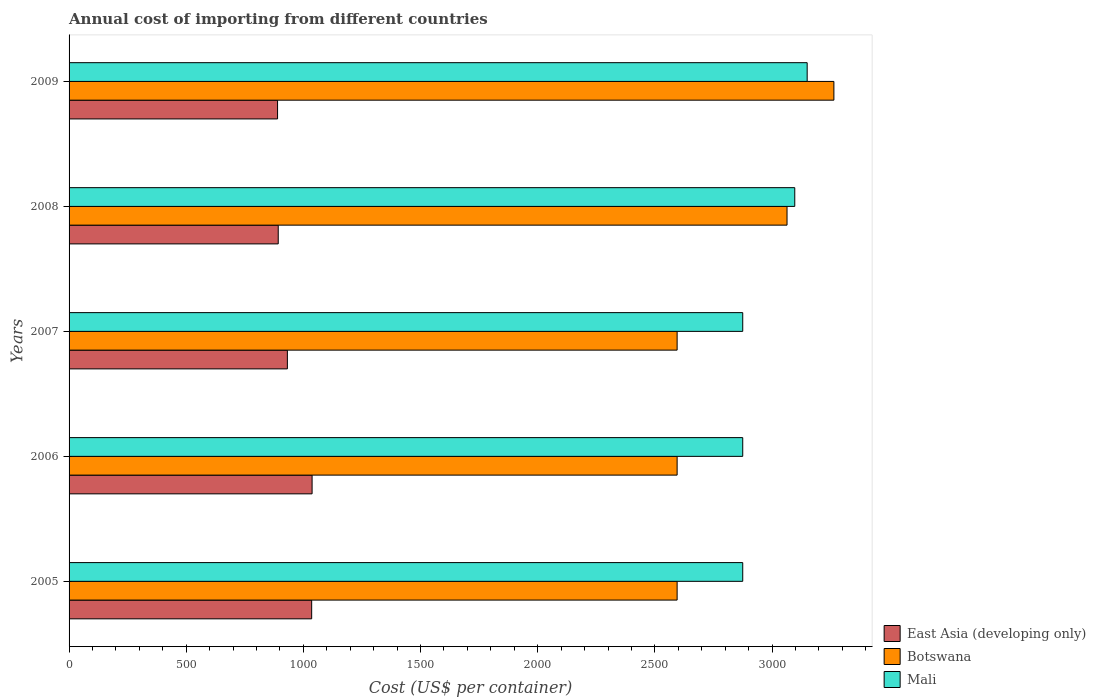Are the number of bars per tick equal to the number of legend labels?
Keep it short and to the point. Yes. Are the number of bars on each tick of the Y-axis equal?
Your answer should be very brief. Yes. How many bars are there on the 4th tick from the top?
Offer a terse response. 3. How many bars are there on the 4th tick from the bottom?
Your response must be concise. 3. In how many cases, is the number of bars for a given year not equal to the number of legend labels?
Provide a succinct answer. 0. What is the total annual cost of importing in Mali in 2009?
Your answer should be very brief. 3150. Across all years, what is the maximum total annual cost of importing in Botswana?
Keep it short and to the point. 3264. Across all years, what is the minimum total annual cost of importing in Botswana?
Give a very brief answer. 2595. In which year was the total annual cost of importing in Mali maximum?
Offer a terse response. 2009. What is the total total annual cost of importing in Botswana in the graph?
Make the answer very short. 1.41e+04. What is the difference between the total annual cost of importing in East Asia (developing only) in 2006 and that in 2007?
Give a very brief answer. 105.5. What is the difference between the total annual cost of importing in Mali in 2006 and the total annual cost of importing in East Asia (developing only) in 2008?
Keep it short and to the point. 1982.35. What is the average total annual cost of importing in Mali per year?
Your answer should be very brief. 2974.4. In the year 2007, what is the difference between the total annual cost of importing in East Asia (developing only) and total annual cost of importing in Mali?
Your response must be concise. -1943.35. In how many years, is the total annual cost of importing in Botswana greater than 400 US$?
Ensure brevity in your answer.  5. What is the ratio of the total annual cost of importing in Botswana in 2007 to that in 2008?
Your answer should be compact. 0.85. Is the total annual cost of importing in East Asia (developing only) in 2007 less than that in 2009?
Offer a terse response. No. Is the difference between the total annual cost of importing in East Asia (developing only) in 2007 and 2009 greater than the difference between the total annual cost of importing in Mali in 2007 and 2009?
Provide a short and direct response. Yes. What is the difference between the highest and the second highest total annual cost of importing in Botswana?
Keep it short and to the point. 200. What is the difference between the highest and the lowest total annual cost of importing in Mali?
Provide a short and direct response. 275. Is the sum of the total annual cost of importing in Mali in 2005 and 2007 greater than the maximum total annual cost of importing in Botswana across all years?
Ensure brevity in your answer.  Yes. What does the 3rd bar from the top in 2005 represents?
Keep it short and to the point. East Asia (developing only). What does the 1st bar from the bottom in 2005 represents?
Give a very brief answer. East Asia (developing only). How many bars are there?
Provide a succinct answer. 15. How many years are there in the graph?
Keep it short and to the point. 5. What is the difference between two consecutive major ticks on the X-axis?
Your answer should be compact. 500. Does the graph contain any zero values?
Offer a very short reply. No. Does the graph contain grids?
Provide a succinct answer. No. Where does the legend appear in the graph?
Offer a very short reply. Bottom right. How many legend labels are there?
Your response must be concise. 3. What is the title of the graph?
Your answer should be very brief. Annual cost of importing from different countries. Does "Senegal" appear as one of the legend labels in the graph?
Ensure brevity in your answer.  No. What is the label or title of the X-axis?
Keep it short and to the point. Cost (US$ per container). What is the label or title of the Y-axis?
Provide a succinct answer. Years. What is the Cost (US$ per container) in East Asia (developing only) in 2005?
Offer a very short reply. 1035.35. What is the Cost (US$ per container) in Botswana in 2005?
Offer a terse response. 2595. What is the Cost (US$ per container) of Mali in 2005?
Ensure brevity in your answer.  2875. What is the Cost (US$ per container) in East Asia (developing only) in 2006?
Provide a short and direct response. 1037.15. What is the Cost (US$ per container) in Botswana in 2006?
Provide a short and direct response. 2595. What is the Cost (US$ per container) of Mali in 2006?
Provide a short and direct response. 2875. What is the Cost (US$ per container) in East Asia (developing only) in 2007?
Your answer should be compact. 931.65. What is the Cost (US$ per container) of Botswana in 2007?
Provide a short and direct response. 2595. What is the Cost (US$ per container) of Mali in 2007?
Keep it short and to the point. 2875. What is the Cost (US$ per container) of East Asia (developing only) in 2008?
Ensure brevity in your answer.  892.65. What is the Cost (US$ per container) in Botswana in 2008?
Your response must be concise. 3064. What is the Cost (US$ per container) in Mali in 2008?
Ensure brevity in your answer.  3097. What is the Cost (US$ per container) in East Asia (developing only) in 2009?
Your response must be concise. 889.75. What is the Cost (US$ per container) in Botswana in 2009?
Offer a very short reply. 3264. What is the Cost (US$ per container) in Mali in 2009?
Your response must be concise. 3150. Across all years, what is the maximum Cost (US$ per container) in East Asia (developing only)?
Ensure brevity in your answer.  1037.15. Across all years, what is the maximum Cost (US$ per container) of Botswana?
Your response must be concise. 3264. Across all years, what is the maximum Cost (US$ per container) in Mali?
Keep it short and to the point. 3150. Across all years, what is the minimum Cost (US$ per container) in East Asia (developing only)?
Offer a very short reply. 889.75. Across all years, what is the minimum Cost (US$ per container) in Botswana?
Make the answer very short. 2595. Across all years, what is the minimum Cost (US$ per container) in Mali?
Your response must be concise. 2875. What is the total Cost (US$ per container) of East Asia (developing only) in the graph?
Your response must be concise. 4786.55. What is the total Cost (US$ per container) of Botswana in the graph?
Offer a terse response. 1.41e+04. What is the total Cost (US$ per container) in Mali in the graph?
Make the answer very short. 1.49e+04. What is the difference between the Cost (US$ per container) in Botswana in 2005 and that in 2006?
Make the answer very short. 0. What is the difference between the Cost (US$ per container) in Mali in 2005 and that in 2006?
Offer a very short reply. 0. What is the difference between the Cost (US$ per container) of East Asia (developing only) in 2005 and that in 2007?
Your answer should be very brief. 103.7. What is the difference between the Cost (US$ per container) of Botswana in 2005 and that in 2007?
Make the answer very short. 0. What is the difference between the Cost (US$ per container) in Mali in 2005 and that in 2007?
Your response must be concise. 0. What is the difference between the Cost (US$ per container) in East Asia (developing only) in 2005 and that in 2008?
Make the answer very short. 142.7. What is the difference between the Cost (US$ per container) in Botswana in 2005 and that in 2008?
Your response must be concise. -469. What is the difference between the Cost (US$ per container) of Mali in 2005 and that in 2008?
Offer a very short reply. -222. What is the difference between the Cost (US$ per container) of East Asia (developing only) in 2005 and that in 2009?
Your response must be concise. 145.6. What is the difference between the Cost (US$ per container) of Botswana in 2005 and that in 2009?
Your answer should be compact. -669. What is the difference between the Cost (US$ per container) of Mali in 2005 and that in 2009?
Offer a very short reply. -275. What is the difference between the Cost (US$ per container) in East Asia (developing only) in 2006 and that in 2007?
Give a very brief answer. 105.5. What is the difference between the Cost (US$ per container) of Mali in 2006 and that in 2007?
Keep it short and to the point. 0. What is the difference between the Cost (US$ per container) in East Asia (developing only) in 2006 and that in 2008?
Make the answer very short. 144.5. What is the difference between the Cost (US$ per container) in Botswana in 2006 and that in 2008?
Your answer should be very brief. -469. What is the difference between the Cost (US$ per container) of Mali in 2006 and that in 2008?
Keep it short and to the point. -222. What is the difference between the Cost (US$ per container) of East Asia (developing only) in 2006 and that in 2009?
Your response must be concise. 147.4. What is the difference between the Cost (US$ per container) of Botswana in 2006 and that in 2009?
Make the answer very short. -669. What is the difference between the Cost (US$ per container) in Mali in 2006 and that in 2009?
Offer a very short reply. -275. What is the difference between the Cost (US$ per container) of Botswana in 2007 and that in 2008?
Offer a very short reply. -469. What is the difference between the Cost (US$ per container) of Mali in 2007 and that in 2008?
Ensure brevity in your answer.  -222. What is the difference between the Cost (US$ per container) in East Asia (developing only) in 2007 and that in 2009?
Provide a succinct answer. 41.9. What is the difference between the Cost (US$ per container) in Botswana in 2007 and that in 2009?
Offer a very short reply. -669. What is the difference between the Cost (US$ per container) in Mali in 2007 and that in 2009?
Keep it short and to the point. -275. What is the difference between the Cost (US$ per container) in East Asia (developing only) in 2008 and that in 2009?
Your answer should be very brief. 2.9. What is the difference between the Cost (US$ per container) in Botswana in 2008 and that in 2009?
Your answer should be very brief. -200. What is the difference between the Cost (US$ per container) of Mali in 2008 and that in 2009?
Offer a very short reply. -53. What is the difference between the Cost (US$ per container) in East Asia (developing only) in 2005 and the Cost (US$ per container) in Botswana in 2006?
Make the answer very short. -1559.65. What is the difference between the Cost (US$ per container) in East Asia (developing only) in 2005 and the Cost (US$ per container) in Mali in 2006?
Give a very brief answer. -1839.65. What is the difference between the Cost (US$ per container) of Botswana in 2005 and the Cost (US$ per container) of Mali in 2006?
Give a very brief answer. -280. What is the difference between the Cost (US$ per container) in East Asia (developing only) in 2005 and the Cost (US$ per container) in Botswana in 2007?
Keep it short and to the point. -1559.65. What is the difference between the Cost (US$ per container) in East Asia (developing only) in 2005 and the Cost (US$ per container) in Mali in 2007?
Provide a succinct answer. -1839.65. What is the difference between the Cost (US$ per container) in Botswana in 2005 and the Cost (US$ per container) in Mali in 2007?
Your response must be concise. -280. What is the difference between the Cost (US$ per container) of East Asia (developing only) in 2005 and the Cost (US$ per container) of Botswana in 2008?
Offer a terse response. -2028.65. What is the difference between the Cost (US$ per container) of East Asia (developing only) in 2005 and the Cost (US$ per container) of Mali in 2008?
Your answer should be very brief. -2061.65. What is the difference between the Cost (US$ per container) of Botswana in 2005 and the Cost (US$ per container) of Mali in 2008?
Your answer should be compact. -502. What is the difference between the Cost (US$ per container) of East Asia (developing only) in 2005 and the Cost (US$ per container) of Botswana in 2009?
Make the answer very short. -2228.65. What is the difference between the Cost (US$ per container) of East Asia (developing only) in 2005 and the Cost (US$ per container) of Mali in 2009?
Your response must be concise. -2114.65. What is the difference between the Cost (US$ per container) in Botswana in 2005 and the Cost (US$ per container) in Mali in 2009?
Provide a succinct answer. -555. What is the difference between the Cost (US$ per container) in East Asia (developing only) in 2006 and the Cost (US$ per container) in Botswana in 2007?
Give a very brief answer. -1557.85. What is the difference between the Cost (US$ per container) of East Asia (developing only) in 2006 and the Cost (US$ per container) of Mali in 2007?
Offer a terse response. -1837.85. What is the difference between the Cost (US$ per container) in Botswana in 2006 and the Cost (US$ per container) in Mali in 2007?
Make the answer very short. -280. What is the difference between the Cost (US$ per container) of East Asia (developing only) in 2006 and the Cost (US$ per container) of Botswana in 2008?
Ensure brevity in your answer.  -2026.85. What is the difference between the Cost (US$ per container) of East Asia (developing only) in 2006 and the Cost (US$ per container) of Mali in 2008?
Keep it short and to the point. -2059.85. What is the difference between the Cost (US$ per container) of Botswana in 2006 and the Cost (US$ per container) of Mali in 2008?
Your answer should be compact. -502. What is the difference between the Cost (US$ per container) of East Asia (developing only) in 2006 and the Cost (US$ per container) of Botswana in 2009?
Provide a short and direct response. -2226.85. What is the difference between the Cost (US$ per container) in East Asia (developing only) in 2006 and the Cost (US$ per container) in Mali in 2009?
Ensure brevity in your answer.  -2112.85. What is the difference between the Cost (US$ per container) in Botswana in 2006 and the Cost (US$ per container) in Mali in 2009?
Your answer should be very brief. -555. What is the difference between the Cost (US$ per container) of East Asia (developing only) in 2007 and the Cost (US$ per container) of Botswana in 2008?
Make the answer very short. -2132.35. What is the difference between the Cost (US$ per container) of East Asia (developing only) in 2007 and the Cost (US$ per container) of Mali in 2008?
Your response must be concise. -2165.35. What is the difference between the Cost (US$ per container) in Botswana in 2007 and the Cost (US$ per container) in Mali in 2008?
Your answer should be very brief. -502. What is the difference between the Cost (US$ per container) of East Asia (developing only) in 2007 and the Cost (US$ per container) of Botswana in 2009?
Ensure brevity in your answer.  -2332.35. What is the difference between the Cost (US$ per container) in East Asia (developing only) in 2007 and the Cost (US$ per container) in Mali in 2009?
Offer a very short reply. -2218.35. What is the difference between the Cost (US$ per container) of Botswana in 2007 and the Cost (US$ per container) of Mali in 2009?
Give a very brief answer. -555. What is the difference between the Cost (US$ per container) in East Asia (developing only) in 2008 and the Cost (US$ per container) in Botswana in 2009?
Make the answer very short. -2371.35. What is the difference between the Cost (US$ per container) of East Asia (developing only) in 2008 and the Cost (US$ per container) of Mali in 2009?
Give a very brief answer. -2257.35. What is the difference between the Cost (US$ per container) in Botswana in 2008 and the Cost (US$ per container) in Mali in 2009?
Offer a very short reply. -86. What is the average Cost (US$ per container) in East Asia (developing only) per year?
Provide a succinct answer. 957.31. What is the average Cost (US$ per container) in Botswana per year?
Provide a short and direct response. 2822.6. What is the average Cost (US$ per container) of Mali per year?
Your answer should be very brief. 2974.4. In the year 2005, what is the difference between the Cost (US$ per container) of East Asia (developing only) and Cost (US$ per container) of Botswana?
Provide a short and direct response. -1559.65. In the year 2005, what is the difference between the Cost (US$ per container) in East Asia (developing only) and Cost (US$ per container) in Mali?
Provide a short and direct response. -1839.65. In the year 2005, what is the difference between the Cost (US$ per container) in Botswana and Cost (US$ per container) in Mali?
Provide a short and direct response. -280. In the year 2006, what is the difference between the Cost (US$ per container) of East Asia (developing only) and Cost (US$ per container) of Botswana?
Your answer should be very brief. -1557.85. In the year 2006, what is the difference between the Cost (US$ per container) in East Asia (developing only) and Cost (US$ per container) in Mali?
Ensure brevity in your answer.  -1837.85. In the year 2006, what is the difference between the Cost (US$ per container) of Botswana and Cost (US$ per container) of Mali?
Make the answer very short. -280. In the year 2007, what is the difference between the Cost (US$ per container) in East Asia (developing only) and Cost (US$ per container) in Botswana?
Give a very brief answer. -1663.35. In the year 2007, what is the difference between the Cost (US$ per container) in East Asia (developing only) and Cost (US$ per container) in Mali?
Provide a short and direct response. -1943.35. In the year 2007, what is the difference between the Cost (US$ per container) in Botswana and Cost (US$ per container) in Mali?
Ensure brevity in your answer.  -280. In the year 2008, what is the difference between the Cost (US$ per container) of East Asia (developing only) and Cost (US$ per container) of Botswana?
Offer a very short reply. -2171.35. In the year 2008, what is the difference between the Cost (US$ per container) in East Asia (developing only) and Cost (US$ per container) in Mali?
Give a very brief answer. -2204.35. In the year 2008, what is the difference between the Cost (US$ per container) in Botswana and Cost (US$ per container) in Mali?
Give a very brief answer. -33. In the year 2009, what is the difference between the Cost (US$ per container) in East Asia (developing only) and Cost (US$ per container) in Botswana?
Your answer should be compact. -2374.25. In the year 2009, what is the difference between the Cost (US$ per container) in East Asia (developing only) and Cost (US$ per container) in Mali?
Offer a terse response. -2260.25. In the year 2009, what is the difference between the Cost (US$ per container) of Botswana and Cost (US$ per container) of Mali?
Provide a succinct answer. 114. What is the ratio of the Cost (US$ per container) of East Asia (developing only) in 2005 to that in 2006?
Give a very brief answer. 1. What is the ratio of the Cost (US$ per container) in East Asia (developing only) in 2005 to that in 2007?
Offer a terse response. 1.11. What is the ratio of the Cost (US$ per container) of Botswana in 2005 to that in 2007?
Your answer should be compact. 1. What is the ratio of the Cost (US$ per container) of Mali in 2005 to that in 2007?
Your answer should be compact. 1. What is the ratio of the Cost (US$ per container) in East Asia (developing only) in 2005 to that in 2008?
Offer a very short reply. 1.16. What is the ratio of the Cost (US$ per container) of Botswana in 2005 to that in 2008?
Give a very brief answer. 0.85. What is the ratio of the Cost (US$ per container) of Mali in 2005 to that in 2008?
Provide a short and direct response. 0.93. What is the ratio of the Cost (US$ per container) of East Asia (developing only) in 2005 to that in 2009?
Keep it short and to the point. 1.16. What is the ratio of the Cost (US$ per container) in Botswana in 2005 to that in 2009?
Give a very brief answer. 0.8. What is the ratio of the Cost (US$ per container) of Mali in 2005 to that in 2009?
Your answer should be compact. 0.91. What is the ratio of the Cost (US$ per container) in East Asia (developing only) in 2006 to that in 2007?
Your answer should be very brief. 1.11. What is the ratio of the Cost (US$ per container) in Mali in 2006 to that in 2007?
Give a very brief answer. 1. What is the ratio of the Cost (US$ per container) of East Asia (developing only) in 2006 to that in 2008?
Your answer should be very brief. 1.16. What is the ratio of the Cost (US$ per container) in Botswana in 2006 to that in 2008?
Keep it short and to the point. 0.85. What is the ratio of the Cost (US$ per container) of Mali in 2006 to that in 2008?
Give a very brief answer. 0.93. What is the ratio of the Cost (US$ per container) of East Asia (developing only) in 2006 to that in 2009?
Offer a very short reply. 1.17. What is the ratio of the Cost (US$ per container) in Botswana in 2006 to that in 2009?
Your answer should be compact. 0.8. What is the ratio of the Cost (US$ per container) of Mali in 2006 to that in 2009?
Your answer should be very brief. 0.91. What is the ratio of the Cost (US$ per container) of East Asia (developing only) in 2007 to that in 2008?
Offer a terse response. 1.04. What is the ratio of the Cost (US$ per container) of Botswana in 2007 to that in 2008?
Ensure brevity in your answer.  0.85. What is the ratio of the Cost (US$ per container) of Mali in 2007 to that in 2008?
Give a very brief answer. 0.93. What is the ratio of the Cost (US$ per container) of East Asia (developing only) in 2007 to that in 2009?
Ensure brevity in your answer.  1.05. What is the ratio of the Cost (US$ per container) in Botswana in 2007 to that in 2009?
Make the answer very short. 0.8. What is the ratio of the Cost (US$ per container) of Mali in 2007 to that in 2009?
Keep it short and to the point. 0.91. What is the ratio of the Cost (US$ per container) of East Asia (developing only) in 2008 to that in 2009?
Provide a succinct answer. 1. What is the ratio of the Cost (US$ per container) in Botswana in 2008 to that in 2009?
Ensure brevity in your answer.  0.94. What is the ratio of the Cost (US$ per container) of Mali in 2008 to that in 2009?
Make the answer very short. 0.98. What is the difference between the highest and the second highest Cost (US$ per container) of East Asia (developing only)?
Your answer should be very brief. 1.8. What is the difference between the highest and the second highest Cost (US$ per container) of Botswana?
Your answer should be very brief. 200. What is the difference between the highest and the second highest Cost (US$ per container) of Mali?
Keep it short and to the point. 53. What is the difference between the highest and the lowest Cost (US$ per container) in East Asia (developing only)?
Offer a terse response. 147.4. What is the difference between the highest and the lowest Cost (US$ per container) of Botswana?
Offer a terse response. 669. What is the difference between the highest and the lowest Cost (US$ per container) of Mali?
Your response must be concise. 275. 